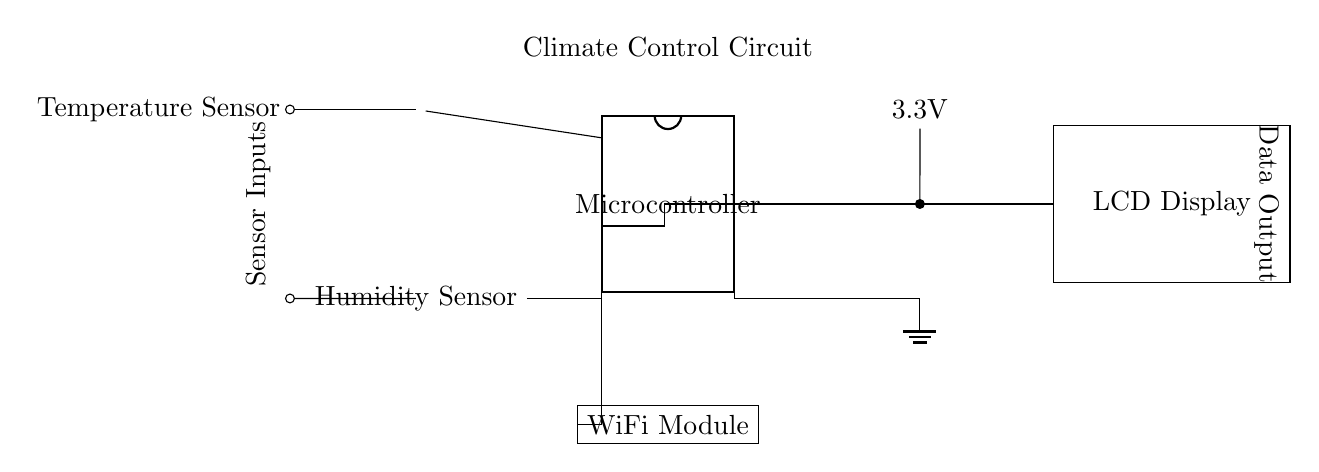What type of sensors are used in the circuit? The circuit uses a thermistor as a temperature sensor and a generic humidity sensor. These components are labeled directly in the diagram, indicating their function.
Answer: Thermistor and Humidity Sensor What is the supply voltage for this circuit? The battery in the circuit is labeled with a voltage of 3.3V, which is the power supply for the microcontroller and other components.
Answer: 3.3V How many pins does the microcontroller have? The microcontroller is indicated as a dipchip with 8 pins, as represented in the labeling on the diagram.
Answer: 8 pins Which components provide the sensor inputs? The sensor inputs in the circuit are from the thermistor and the humidity sensor, which connect directly to specific pins on the microcontroller for processing.
Answer: Thermistor and Humidity Sensor Where does the output data go after processing? The processed output data from the microcontroller is directed to an LCD display, as shown in the diagram, indicating where the information will be presented.
Answer: LCD Display What role does the WiFi module perform in this circuit? The WiFi module connects to the microcontroller, allowing for wireless communication of the climate data collected from the sensors, making it an essential component for networking.
Answer: Wireless communication Which pin of the microcontroller is connected to ground? The ground is connected to pin 5 of the microcontroller, which is marked clearly in the diagram, showing where the circuit's ground reference is established.
Answer: Pin 5 